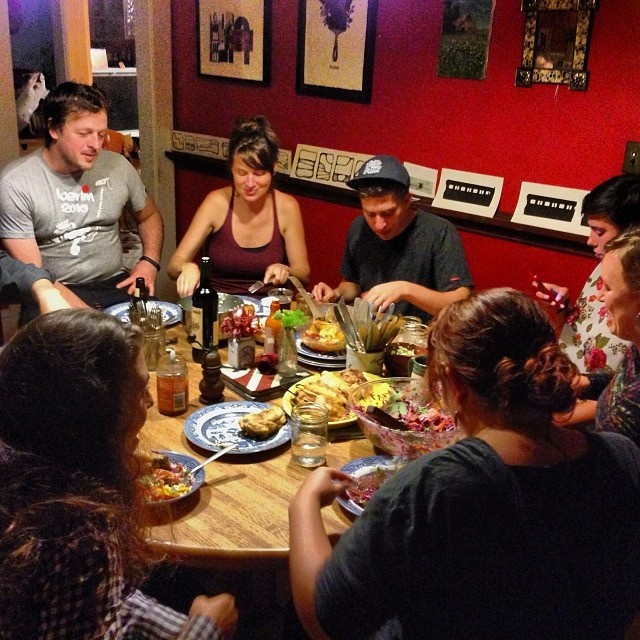Describe the objects in this image and their specific colors. I can see people in lightpink, black, maroon, and brown tones, dining table in lightpink, tan, black, maroon, and brown tones, people in lightpink, black, maroon, and gray tones, people in lightpink, darkgray, black, lightgray, and gray tones, and people in lightpink, black, maroon, tan, and brown tones in this image. 